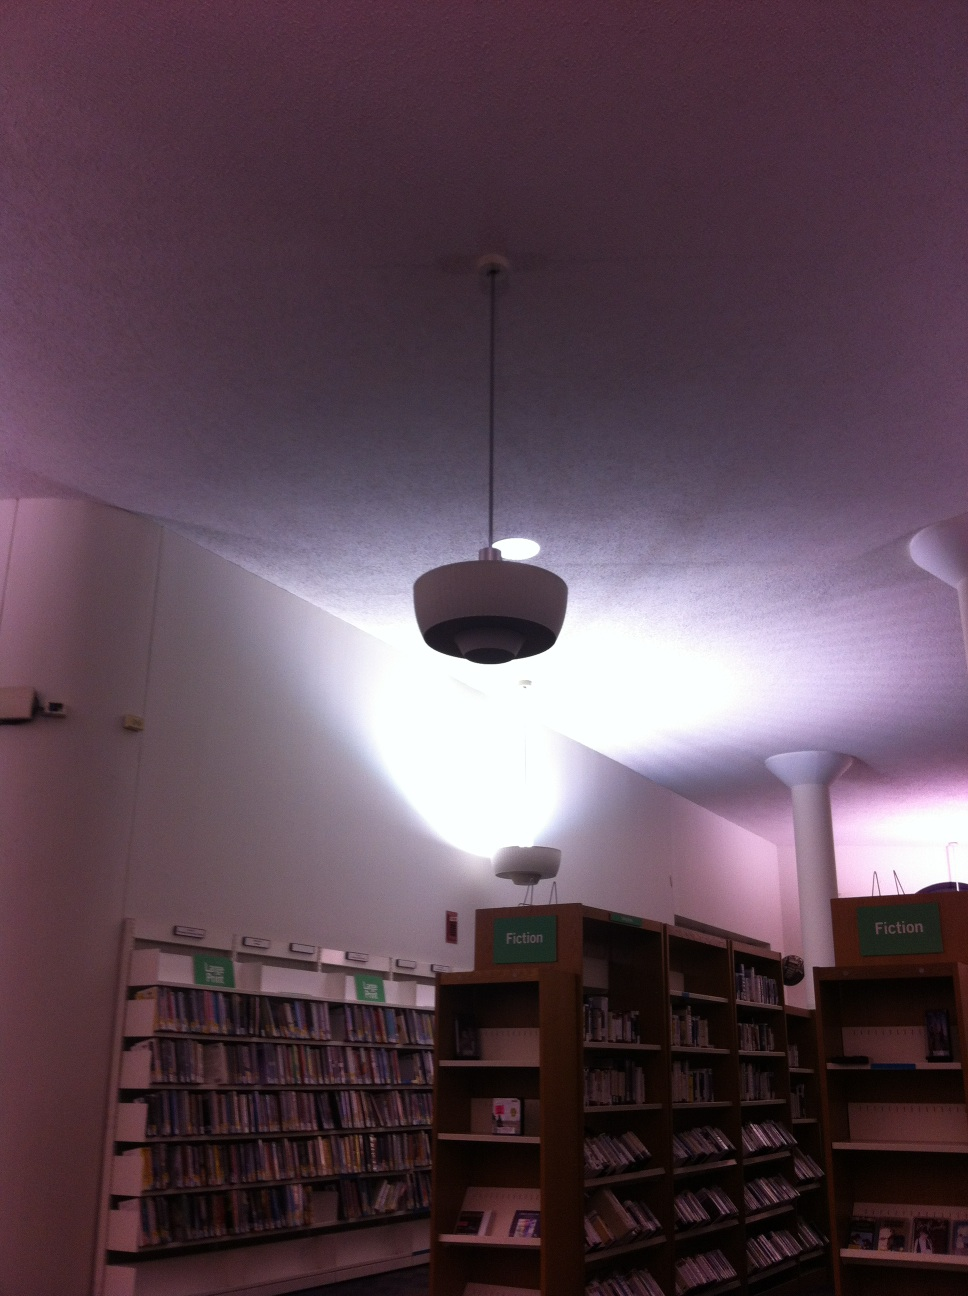Can you describe a day in the life of this library? A typical day in this library starts with the staff preparing the space by organizing books and setting up the reading areas. As the doors open, patrons from diverse backgrounds can be seen walking in, some heading straight to specific sections while others browse leisurely. Throughout the day, students fill the study tables, book lovers immerse themselves in their favorite genres, and children explore the world of literature in the kids' section. The library also witnesses community events, with people engaging in discussions, workshops, and educational programs. It's a place that pulses with quiet activity, offering a sanctuary of knowledge and community spirit. 